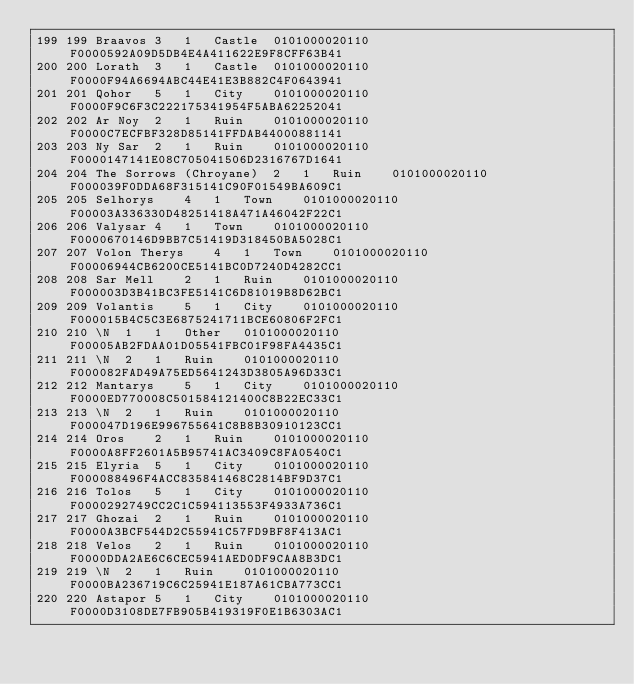Convert code to text. <code><loc_0><loc_0><loc_500><loc_500><_SQL_>199	199	Braavos	3	1	Castle	0101000020110F0000592A09D5DB4E4A411622E9F8CFF63B41
200	200	Lorath	3	1	Castle	0101000020110F0000F94A6694ABC44E41E3B882C4F0643941
201	201	Qohor	5	1	City	0101000020110F0000F9C6F3C222175341954F5ABA62252041
202	202	Ar Noy	2	1	Ruin	0101000020110F0000C7ECFBF328D85141FFDAB44000881141
203	203	Ny Sar	2	1	Ruin	0101000020110F0000147141E08C705041506D2316767D1641
204	204	The Sorrows (Chroyane)	2	1	Ruin	0101000020110F000039F0DDA68F315141C90F01549BA609C1
205	205	Selhorys	4	1	Town	0101000020110F00003A336330D48251418A471A46042F22C1
206	206	Valysar	4	1	Town	0101000020110F0000670146D9BB7C51419D318450BA5028C1
207	207	Volon Therys	4	1	Town	0101000020110F00006944CB6200CE5141BC0D7240D4282CC1
208	208	Sar Mell	2	1	Ruin	0101000020110F000003D3B41BC3FE5141C6D81019B8D62BC1
209	209	Volantis	5	1	City	0101000020110F000015B4C5C3E6875241711BCE60806F2FC1
210	210	\N	1	1	Other	0101000020110F00005AB2FDAA01D05541FBC01F98FA4435C1
211	211	\N	2	1	Ruin	0101000020110F000082FAD49A75ED5641243D3805A96D33C1
212	212	Mantarys	5	1	City	0101000020110F0000ED770008C501584121400C8B22EC33C1
213	213	\N	2	1	Ruin	0101000020110F000047D196E996755641C8B8B30910123CC1
214	214	Oros	2	1	Ruin	0101000020110F0000A8FF2601A5B95741AC3409C8FA0540C1
215	215	Elyria	5	1	City	0101000020110F000088496F4ACC835841468C2814BF9D37C1
216	216	Tolos	5	1	City	0101000020110F0000292749CC2C1C594113553F4933A736C1
217	217	Ghozai	2	1	Ruin	0101000020110F0000A3BCF544D2C55941C57FD9BF8F413AC1
218	218	Velos	2	1	Ruin	0101000020110F0000DDA2AE6C6CEC5941AED0DF9CAA8B3DC1
219	219	\N	2	1	Ruin	0101000020110F0000BA236719C6C25941E187A61CBA773CC1
220	220	Astapor	5	1	City	0101000020110F0000D3108DE7FB905B419319F0E1B6303AC1</code> 